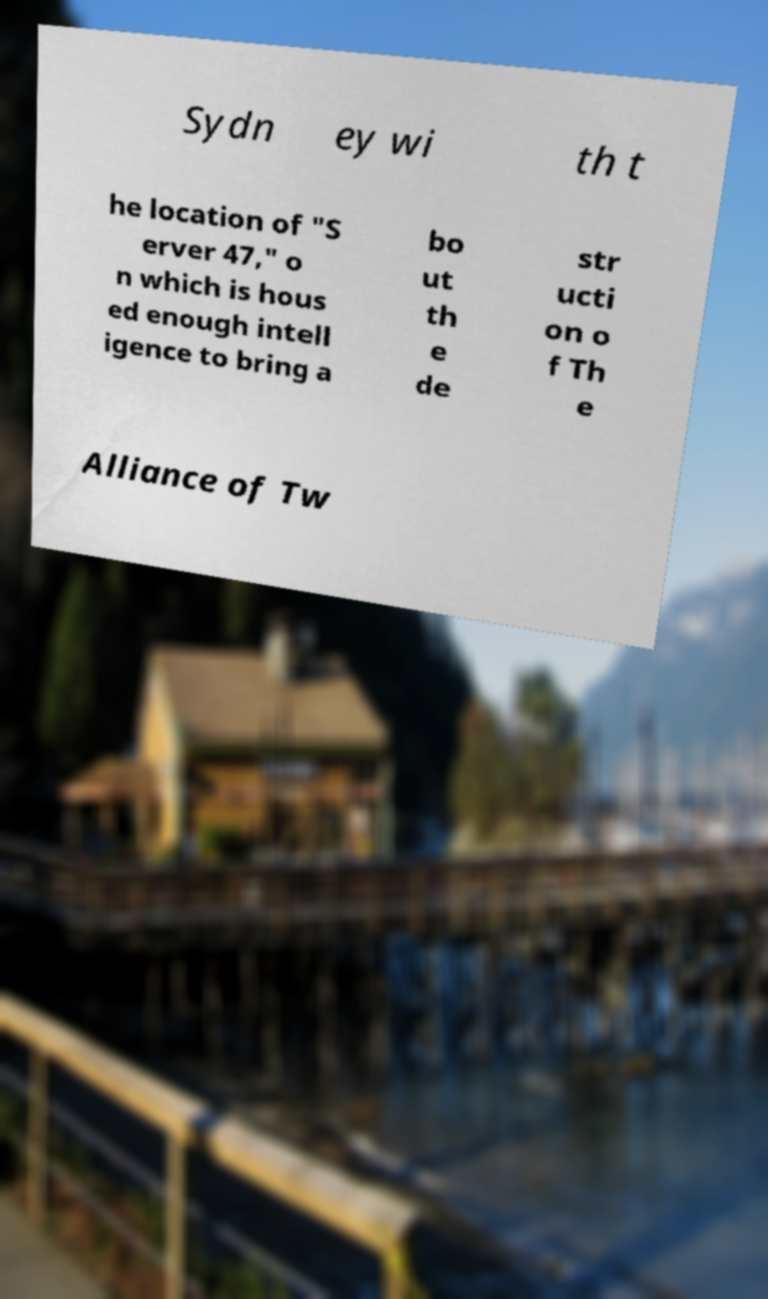Can you accurately transcribe the text from the provided image for me? Sydn ey wi th t he location of "S erver 47," o n which is hous ed enough intell igence to bring a bo ut th e de str ucti on o f Th e Alliance of Tw 